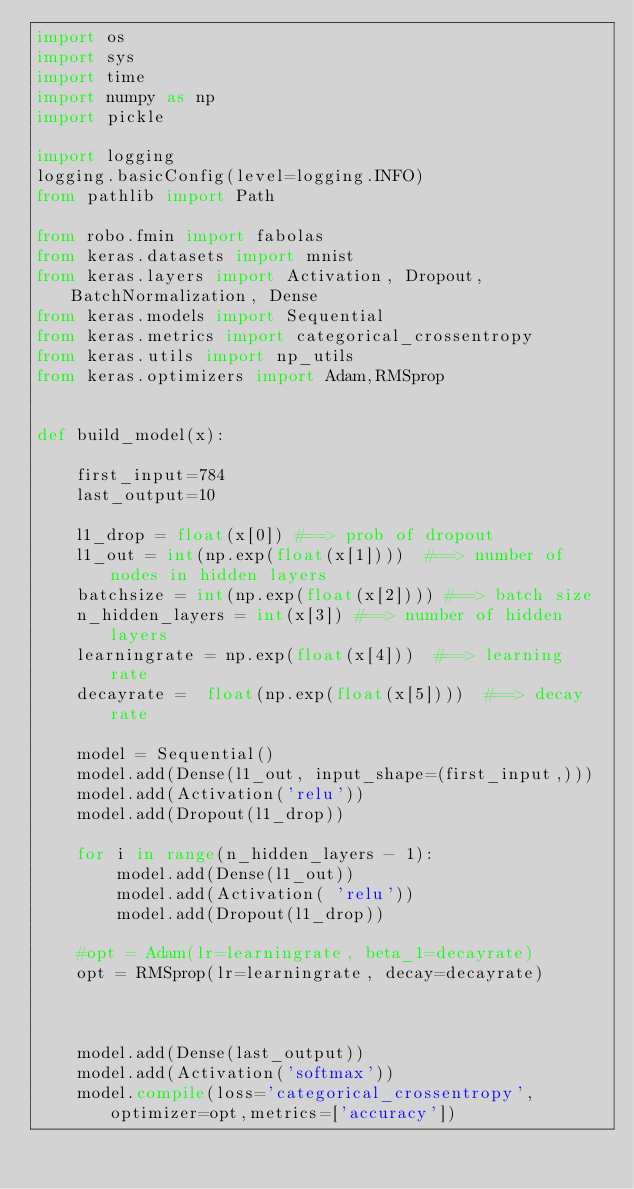<code> <loc_0><loc_0><loc_500><loc_500><_Python_>import os
import sys
import time
import numpy as np
import pickle 

import logging
logging.basicConfig(level=logging.INFO)
from pathlib import Path

from robo.fmin import fabolas
from keras.datasets import mnist
from keras.layers import Activation, Dropout, BatchNormalization, Dense
from keras.models import Sequential
from keras.metrics import categorical_crossentropy
from keras.utils import np_utils
from keras.optimizers import Adam,RMSprop


def build_model(x):
    
    first_input=784
    last_output=10
        
    l1_drop = float(x[0]) #==> prob of dropout
    l1_out = int(np.exp(float(x[1])))  #==> number of nodes in hidden layers
    batchsize = int(np.exp(float(x[2]))) #==> batch size
    n_hidden_layers = int(x[3]) #==> number of hidden layers
    learningrate = np.exp(float(x[4]))  #==> learning rate
    decayrate =  float(np.exp(float(x[5])))  #==> decay rate

    model = Sequential()
    model.add(Dense(l1_out, input_shape=(first_input,)))
    model.add(Activation('relu'))
    model.add(Dropout(l1_drop))
    
    for i in range(n_hidden_layers - 1):
        model.add(Dense(l1_out))
        model.add(Activation( 'relu'))
        model.add(Dropout(l1_drop))
    
    #opt = Adam(lr=learningrate, beta_1=decayrate)
    opt = RMSprop(lr=learningrate, decay=decayrate)
    


    model.add(Dense(last_output))
    model.add(Activation('softmax'))
    model.compile(loss='categorical_crossentropy',optimizer=opt,metrics=['accuracy'])</code> 